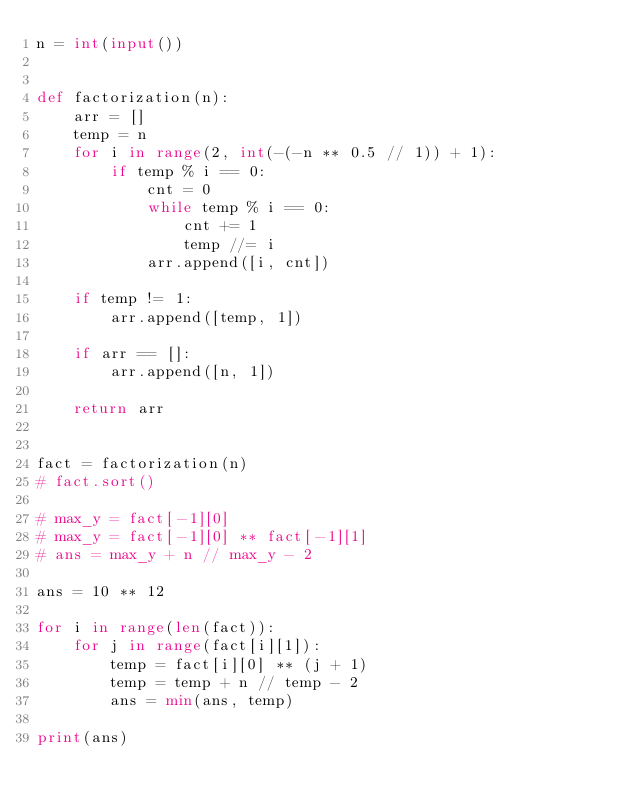<code> <loc_0><loc_0><loc_500><loc_500><_Python_>n = int(input())


def factorization(n):
    arr = []
    temp = n
    for i in range(2, int(-(-n ** 0.5 // 1)) + 1):
        if temp % i == 0:
            cnt = 0
            while temp % i == 0:
                cnt += 1
                temp //= i
            arr.append([i, cnt])

    if temp != 1:
        arr.append([temp, 1])

    if arr == []:
        arr.append([n, 1])

    return arr


fact = factorization(n)
# fact.sort()

# max_y = fact[-1][0]
# max_y = fact[-1][0] ** fact[-1][1]
# ans = max_y + n // max_y - 2

ans = 10 ** 12

for i in range(len(fact)):
    for j in range(fact[i][1]):
        temp = fact[i][0] ** (j + 1)
        temp = temp + n // temp - 2
        ans = min(ans, temp)

print(ans)
</code> 